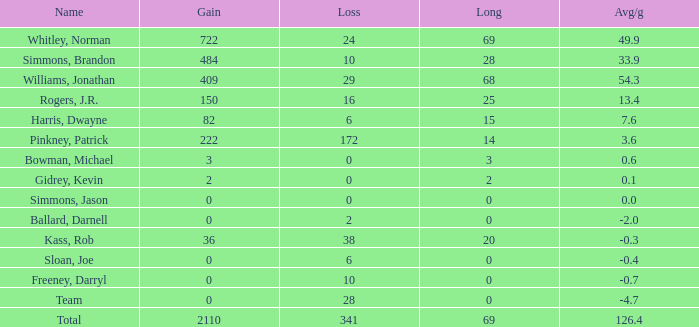What is the lowest Loss, when Long is less than 0? None. 